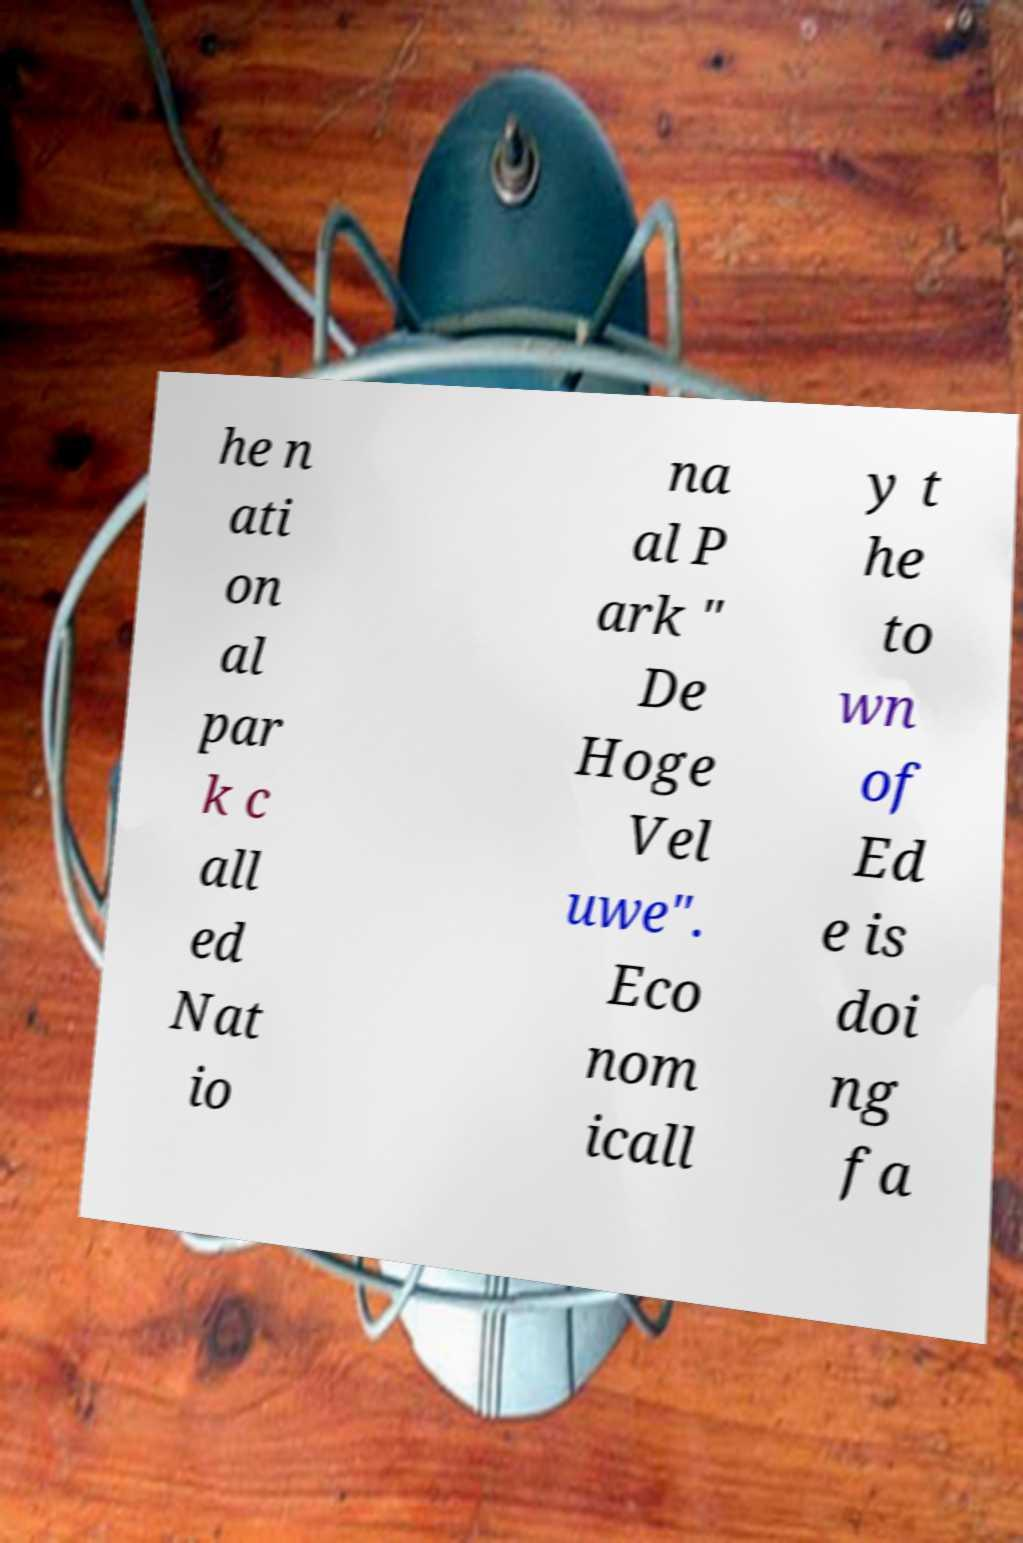Please read and relay the text visible in this image. What does it say? he n ati on al par k c all ed Nat io na al P ark " De Hoge Vel uwe". Eco nom icall y t he to wn of Ed e is doi ng fa 